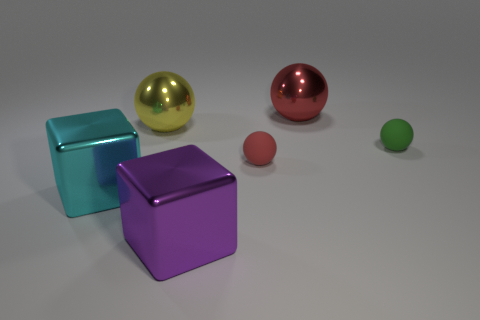Do the large purple object and the block to the left of the big purple shiny cube have the same material?
Offer a terse response. Yes. The large purple object right of the large yellow ball to the left of the purple metal object is what shape?
Ensure brevity in your answer.  Cube. Is there anything else that has the same material as the large cyan object?
Provide a succinct answer. Yes. What is the shape of the tiny green matte object?
Offer a terse response. Sphere. There is a rubber object left of the green object in front of the yellow thing; how big is it?
Your answer should be very brief. Small. Is the number of small red balls to the right of the green sphere the same as the number of big metal things that are behind the purple metallic cube?
Provide a short and direct response. No. There is a big thing that is both behind the large purple block and in front of the yellow metal object; what is its material?
Your answer should be very brief. Metal. There is a cyan cube; is it the same size as the thing that is in front of the big cyan metallic object?
Provide a short and direct response. Yes. Is the number of red metallic balls in front of the large purple metallic object greater than the number of tiny red spheres?
Your response must be concise. No. There is a tiny rubber object that is on the left side of the tiny ball behind the ball in front of the green matte object; what color is it?
Provide a short and direct response. Red. 